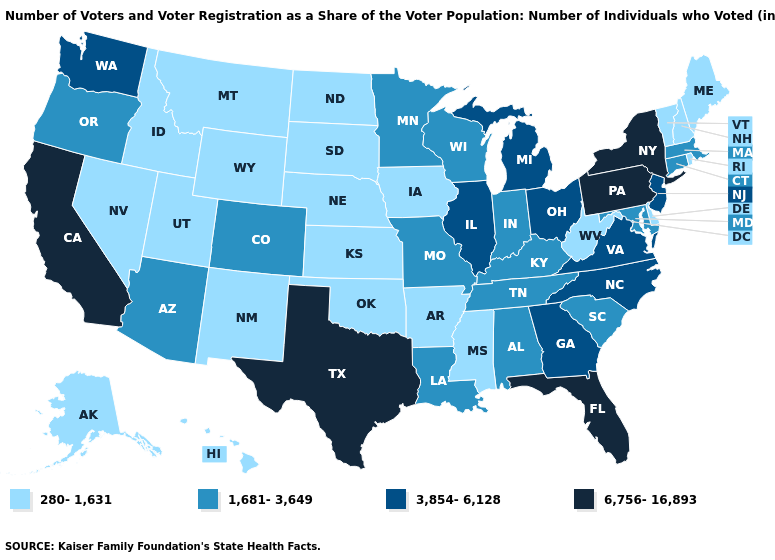Name the states that have a value in the range 1,681-3,649?
Answer briefly. Alabama, Arizona, Colorado, Connecticut, Indiana, Kentucky, Louisiana, Maryland, Massachusetts, Minnesota, Missouri, Oregon, South Carolina, Tennessee, Wisconsin. What is the value of Tennessee?
Quick response, please. 1,681-3,649. How many symbols are there in the legend?
Concise answer only. 4. Name the states that have a value in the range 1,681-3,649?
Quick response, please. Alabama, Arizona, Colorado, Connecticut, Indiana, Kentucky, Louisiana, Maryland, Massachusetts, Minnesota, Missouri, Oregon, South Carolina, Tennessee, Wisconsin. What is the highest value in the South ?
Answer briefly. 6,756-16,893. How many symbols are there in the legend?
Short answer required. 4. What is the highest value in states that border Michigan?
Short answer required. 3,854-6,128. Name the states that have a value in the range 3,854-6,128?
Quick response, please. Georgia, Illinois, Michigan, New Jersey, North Carolina, Ohio, Virginia, Washington. What is the value of Alaska?
Concise answer only. 280-1,631. Name the states that have a value in the range 6,756-16,893?
Answer briefly. California, Florida, New York, Pennsylvania, Texas. What is the value of South Carolina?
Be succinct. 1,681-3,649. Which states hav the highest value in the South?
Be succinct. Florida, Texas. Name the states that have a value in the range 6,756-16,893?
Quick response, please. California, Florida, New York, Pennsylvania, Texas. Does Pennsylvania have the highest value in the Northeast?
Write a very short answer. Yes. Name the states that have a value in the range 3,854-6,128?
Be succinct. Georgia, Illinois, Michigan, New Jersey, North Carolina, Ohio, Virginia, Washington. 